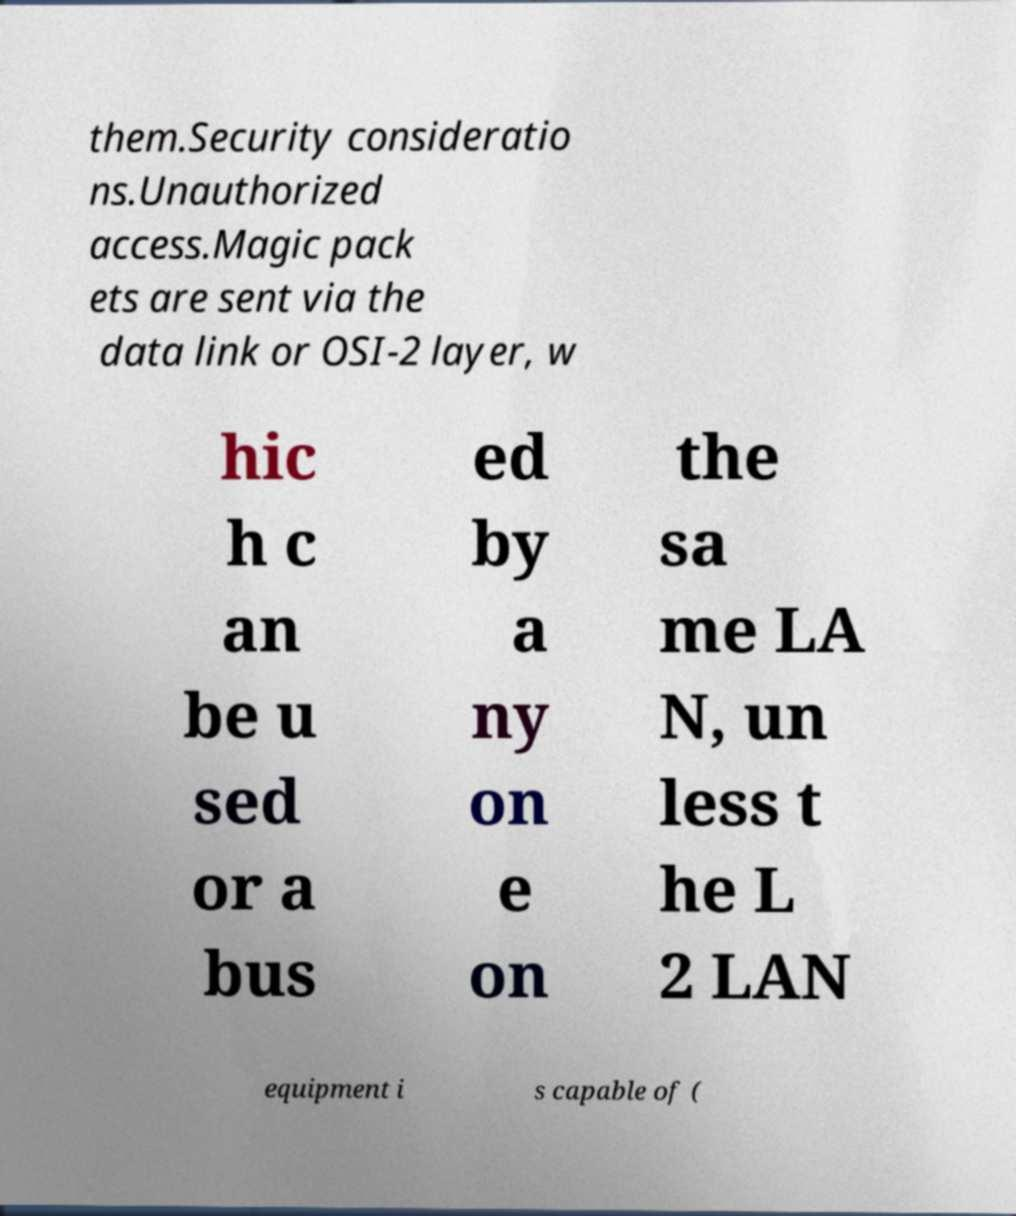Please identify and transcribe the text found in this image. them.Security consideratio ns.Unauthorized access.Magic pack ets are sent via the data link or OSI-2 layer, w hic h c an be u sed or a bus ed by a ny on e on the sa me LA N, un less t he L 2 LAN equipment i s capable of ( 